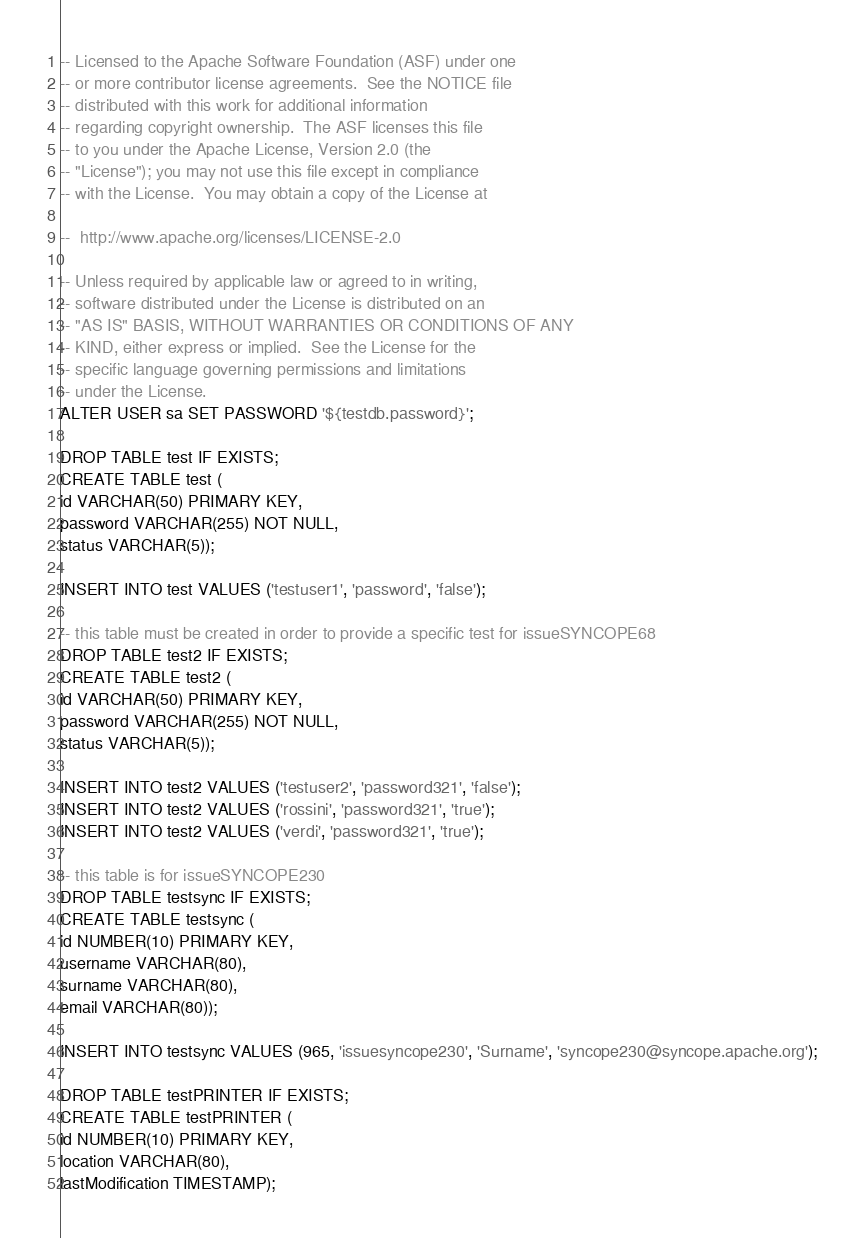<code> <loc_0><loc_0><loc_500><loc_500><_SQL_>-- Licensed to the Apache Software Foundation (ASF) under one
-- or more contributor license agreements.  See the NOTICE file
-- distributed with this work for additional information
-- regarding copyright ownership.  The ASF licenses this file
-- to you under the Apache License, Version 2.0 (the
-- "License"); you may not use this file except in compliance
-- with the License.  You may obtain a copy of the License at

--  http://www.apache.org/licenses/LICENSE-2.0

-- Unless required by applicable law or agreed to in writing,
-- software distributed under the License is distributed on an
-- "AS IS" BASIS, WITHOUT WARRANTIES OR CONDITIONS OF ANY
-- KIND, either express or implied.  See the License for the
-- specific language governing permissions and limitations
-- under the License.
ALTER USER sa SET PASSWORD '${testdb.password}';

DROP TABLE test IF EXISTS;
CREATE TABLE test (
id VARCHAR(50) PRIMARY KEY,
password VARCHAR(255) NOT NULL,
status VARCHAR(5));

INSERT INTO test VALUES ('testuser1', 'password', 'false');

-- this table must be created in order to provide a specific test for issueSYNCOPE68
DROP TABLE test2 IF EXISTS;
CREATE TABLE test2 (
id VARCHAR(50) PRIMARY KEY,
password VARCHAR(255) NOT NULL,
status VARCHAR(5));

INSERT INTO test2 VALUES ('testuser2', 'password321', 'false');
INSERT INTO test2 VALUES ('rossini', 'password321', 'true');
INSERT INTO test2 VALUES ('verdi', 'password321', 'true');

-- this table is for issueSYNCOPE230
DROP TABLE testsync IF EXISTS;
CREATE TABLE testsync (
id NUMBER(10) PRIMARY KEY,
username VARCHAR(80),
surname VARCHAR(80),
email VARCHAR(80));

INSERT INTO testsync VALUES (965, 'issuesyncope230', 'Surname', 'syncope230@syncope.apache.org');

DROP TABLE testPRINTER IF EXISTS;
CREATE TABLE testPRINTER (
id NUMBER(10) PRIMARY KEY,
location VARCHAR(80),
lastModification TIMESTAMP);</code> 